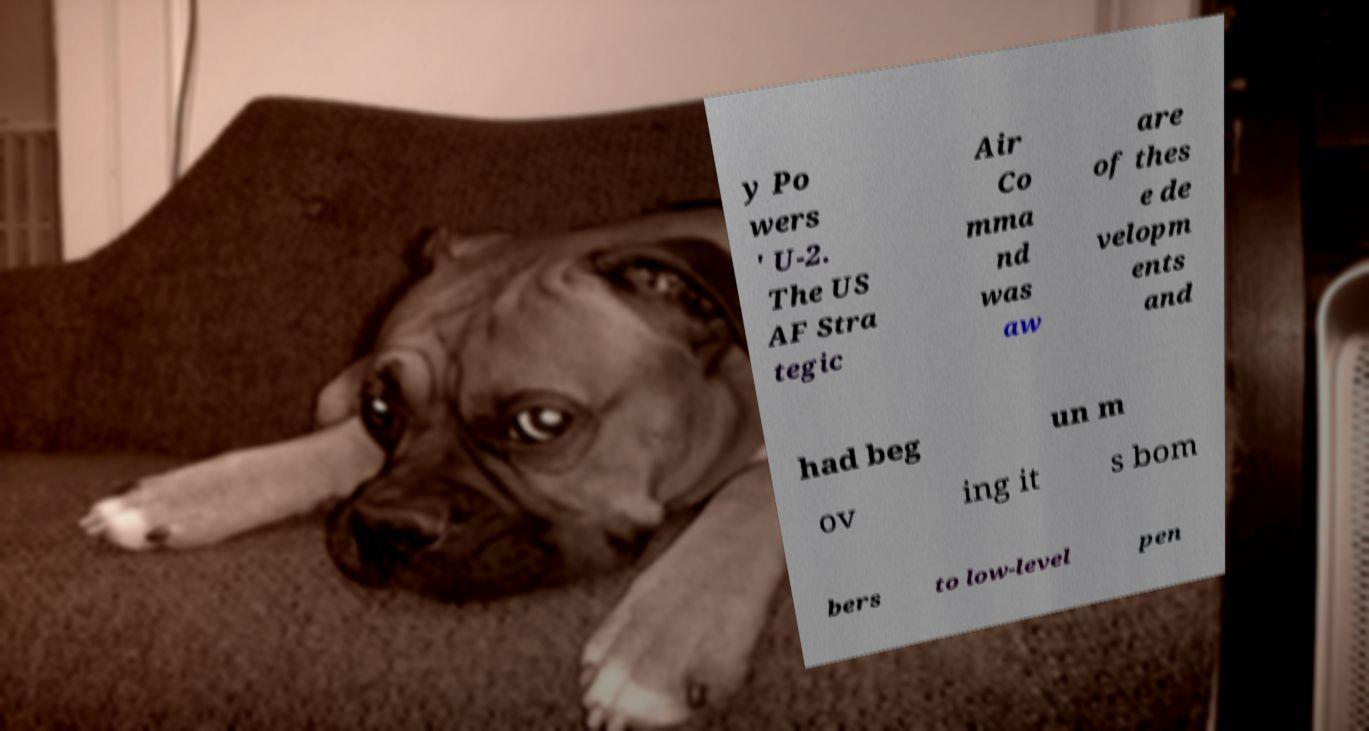I need the written content from this picture converted into text. Can you do that? y Po wers ' U-2. The US AF Stra tegic Air Co mma nd was aw are of thes e de velopm ents and had beg un m ov ing it s bom bers to low-level pen 